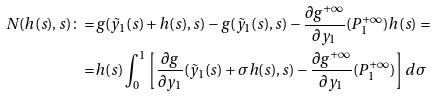<formula> <loc_0><loc_0><loc_500><loc_500>N ( h ( s ) , s ) \colon = & g ( \tilde { y } _ { 1 } ( s ) + h ( s ) , s ) - g ( \tilde { y } _ { 1 } ( s ) , s ) - \frac { \partial g ^ { + \infty } } { \partial y _ { 1 } } ( P _ { 1 } ^ { + \infty } ) h ( s ) = \\ = & h ( s ) \int _ { 0 } ^ { 1 } \left [ \frac { \partial g } { \partial y _ { 1 } } ( \tilde { y } _ { 1 } ( s ) + \sigma h ( s ) , s ) - \frac { \partial g ^ { + \infty } } { \partial y _ { 1 } } ( P _ { 1 } ^ { + \infty } ) \right ] d \sigma</formula> 